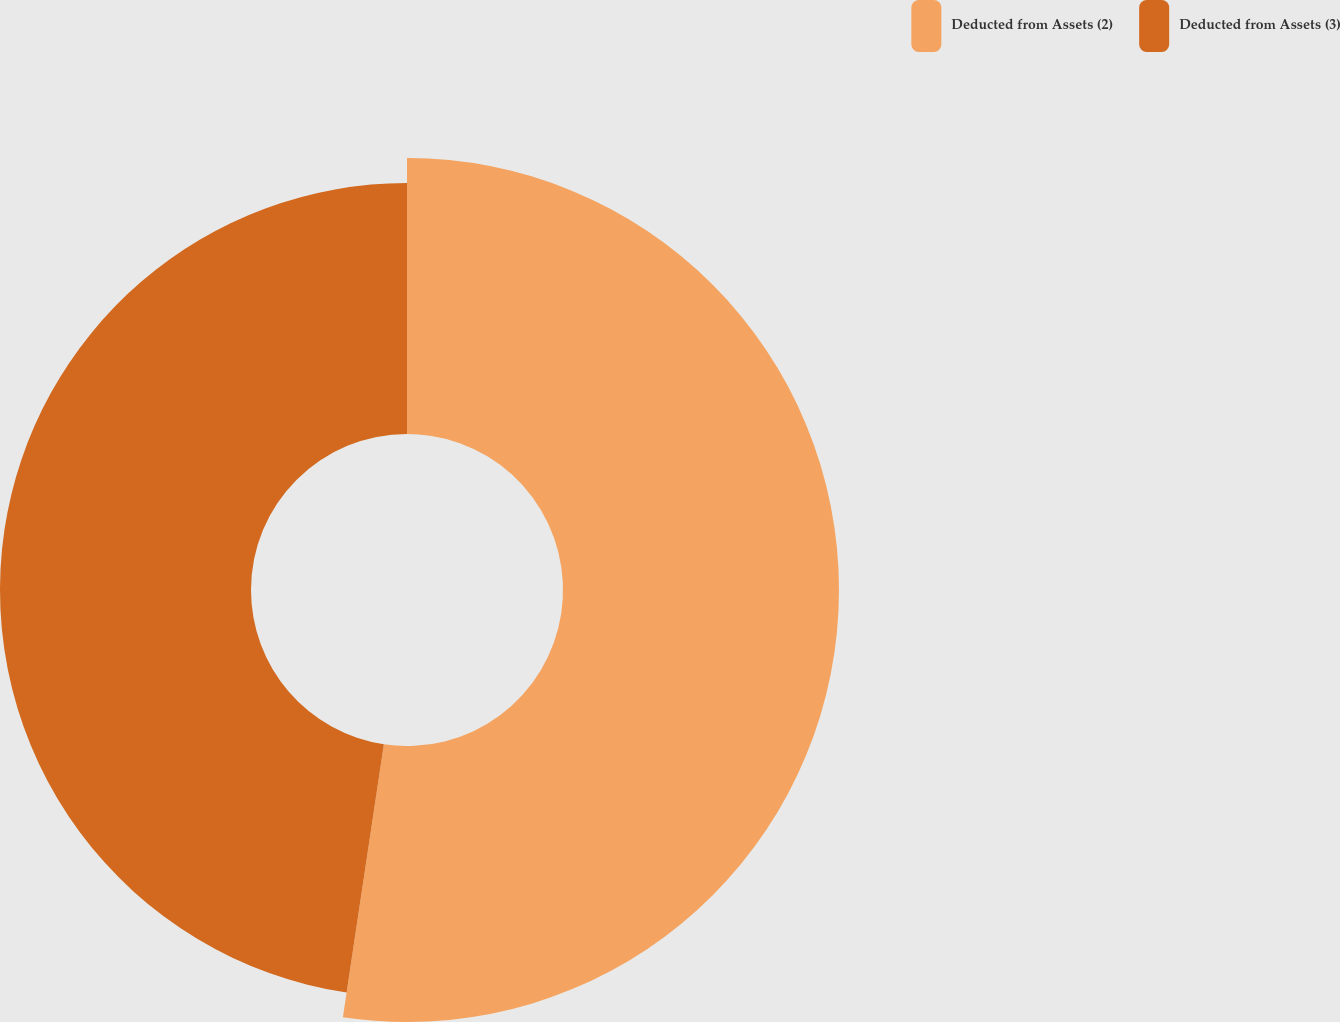Convert chart to OTSL. <chart><loc_0><loc_0><loc_500><loc_500><pie_chart><fcel>Deducted from Assets (2)<fcel>Deducted from Assets (3)<nl><fcel>52.37%<fcel>47.63%<nl></chart> 